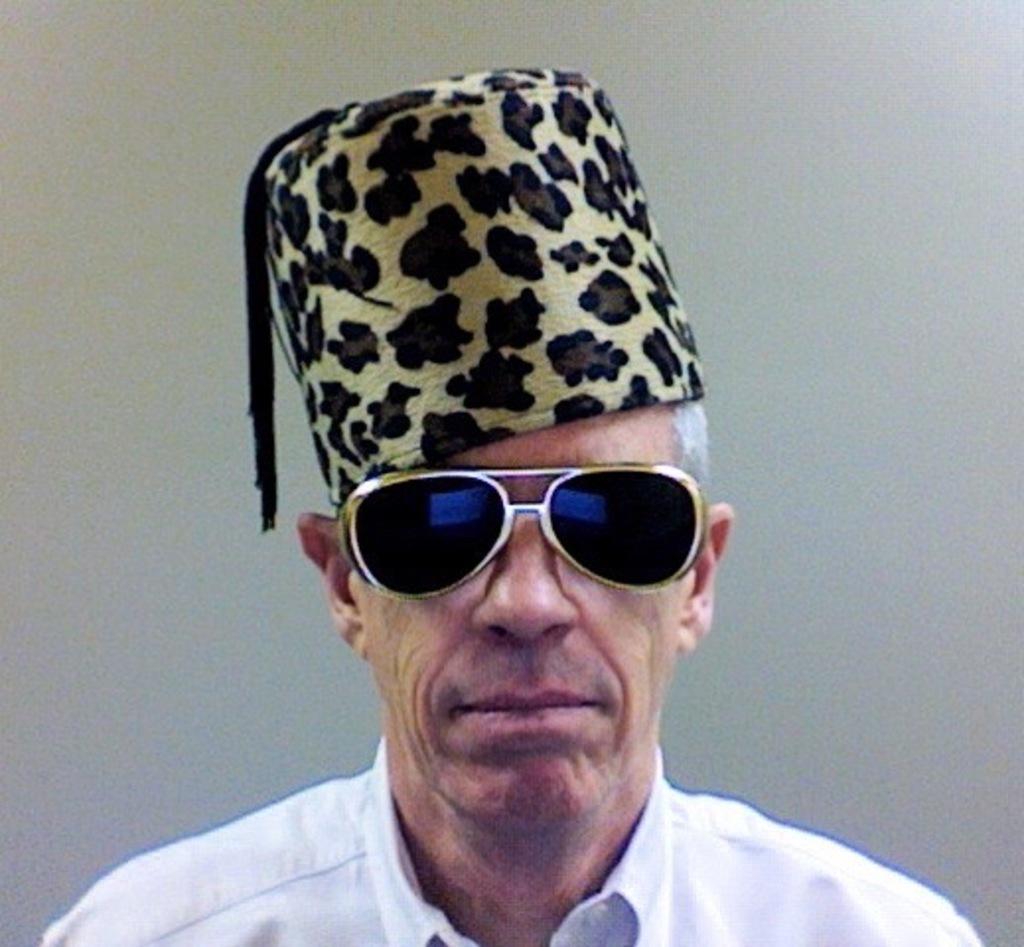In one or two sentences, can you explain what this image depicts? In this image I can see a person wearing the spectacles and a cap on the head. 